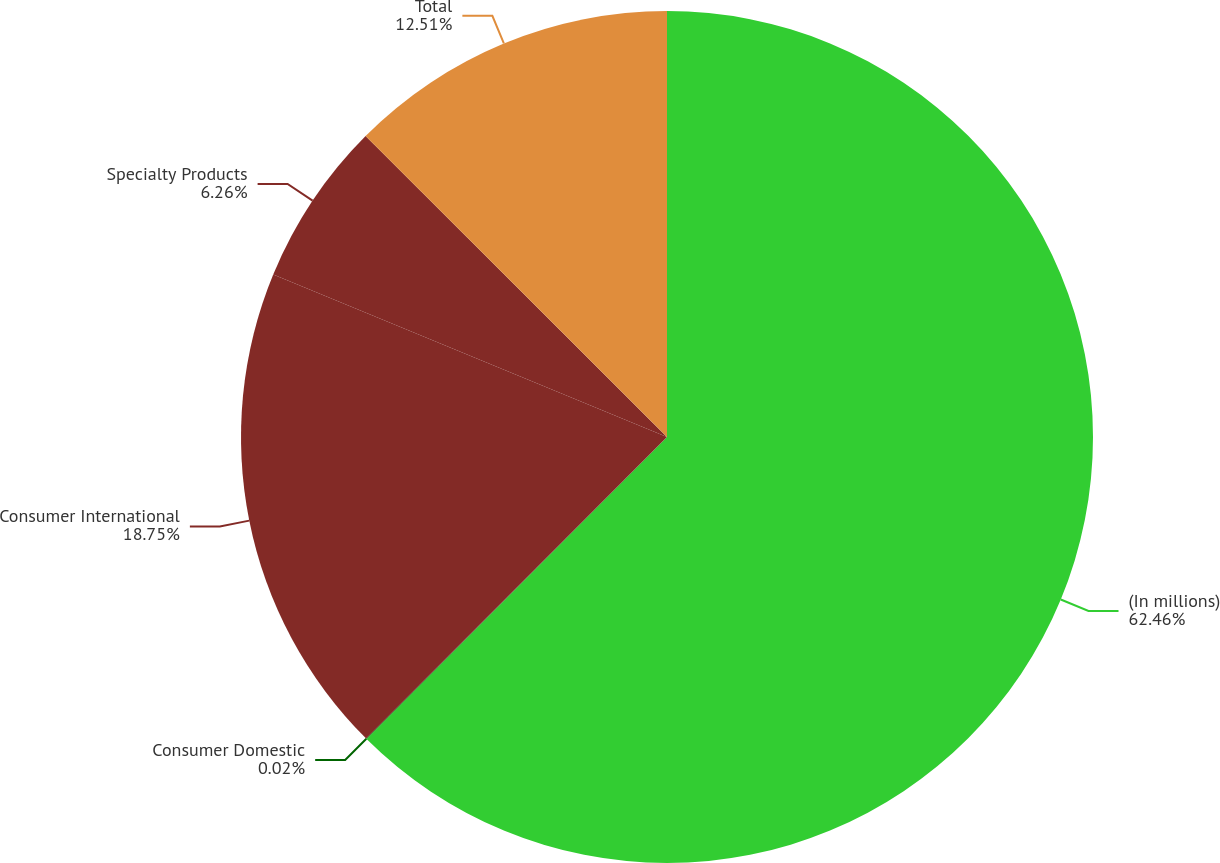Convert chart. <chart><loc_0><loc_0><loc_500><loc_500><pie_chart><fcel>(In millions)<fcel>Consumer Domestic<fcel>Consumer International<fcel>Specialty Products<fcel>Total<nl><fcel>62.46%<fcel>0.02%<fcel>18.75%<fcel>6.26%<fcel>12.51%<nl></chart> 